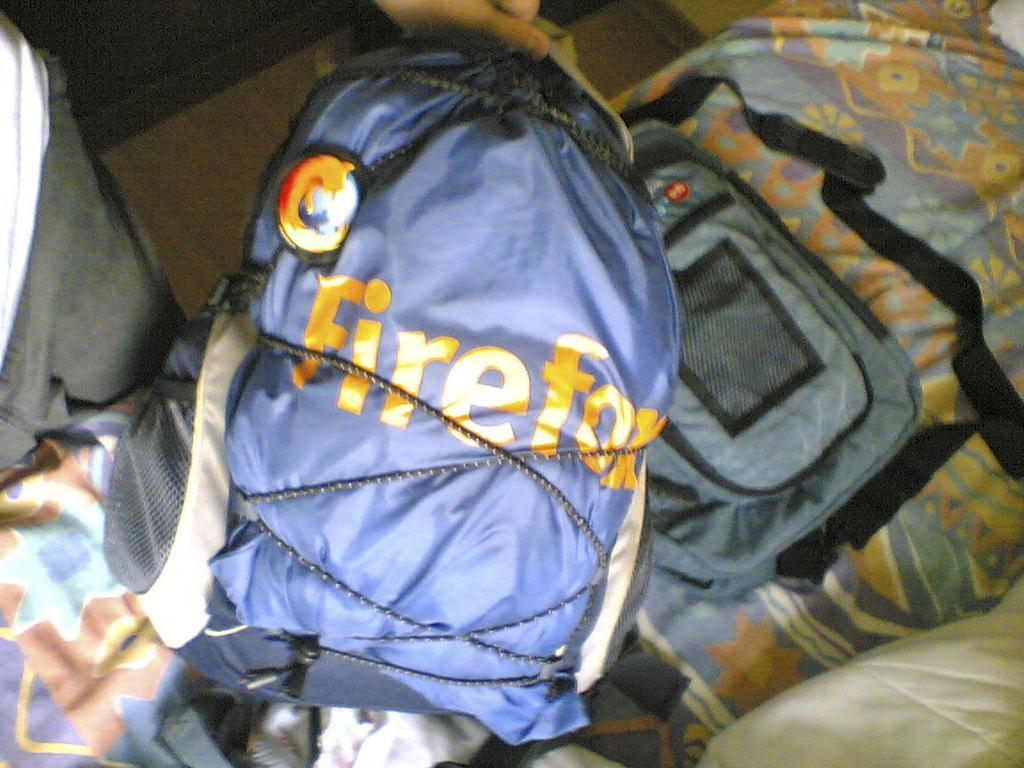What color is the bag in the picture? The bag in the picture is blue. Where is the bag located? The bag is on a bed. Who is holding the bag? A man is holding the bag. What is written on the bag? "Firefox" is written on the bag. What time of day is it in the image, and is the grandmother present? The time of day is not mentioned in the image, and there is no indication of a grandmother being present. 